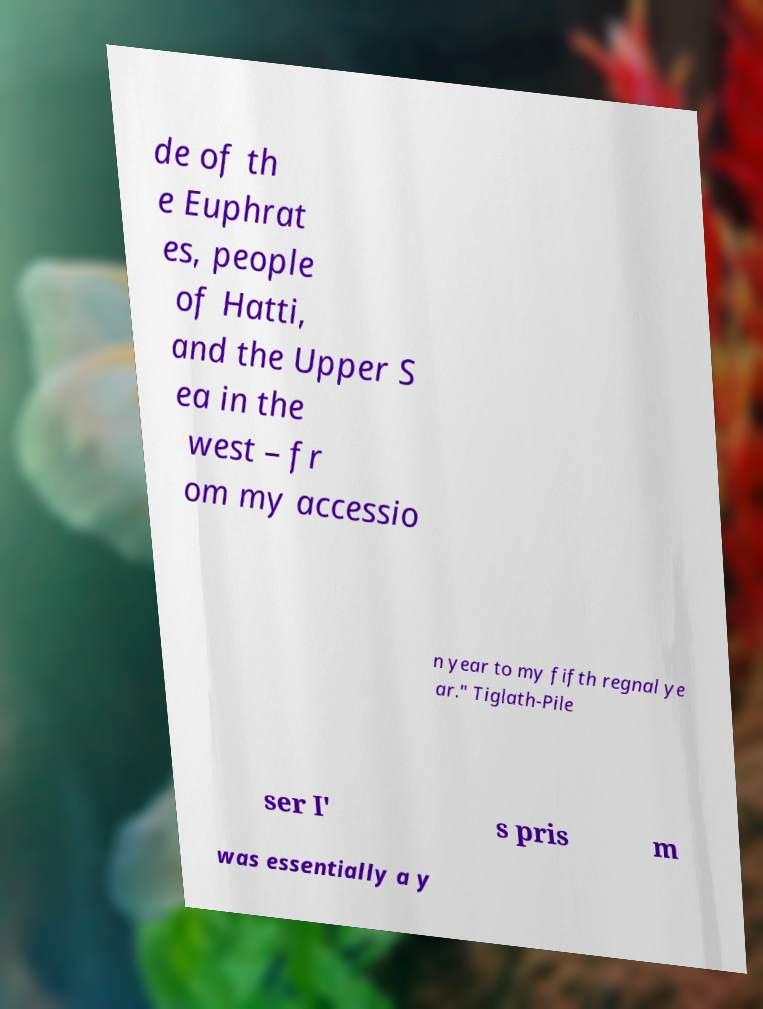Could you assist in decoding the text presented in this image and type it out clearly? de of th e Euphrat es, people of Hatti, and the Upper S ea in the west – fr om my accessio n year to my fifth regnal ye ar." Tiglath-Pile ser I' s pris m was essentially a y 